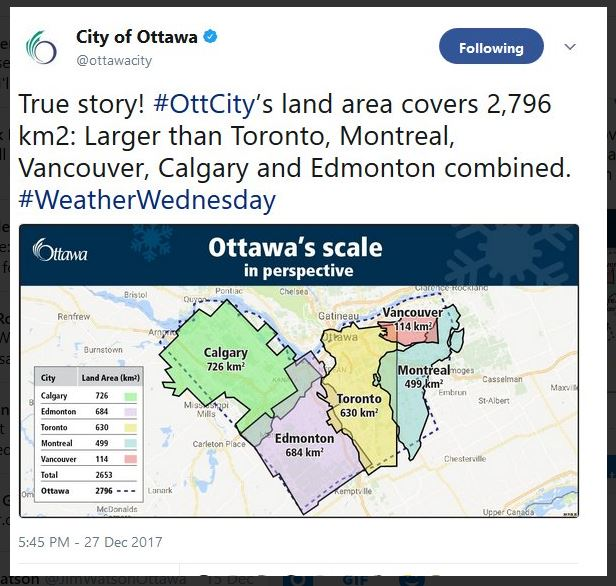Can you describe how the large land area of Ottawa might influence its transportation systems? Ottawa's vast land area significantly influences its transportation systems. With a larger area to cover, the city requires an extensive network of roads, highways, and public transit routes. This can mean longer travel times for residents and a need for efficient public transit solutions to connect different parts of the city. The city might invest in more frequent and diverse public transportation options, like buses, trains, and bike paths, to accommodate the spread-out nature of its population. Additionally, the maintenance and expansion of such a transportation network could be more costly due to the large area it serves. 